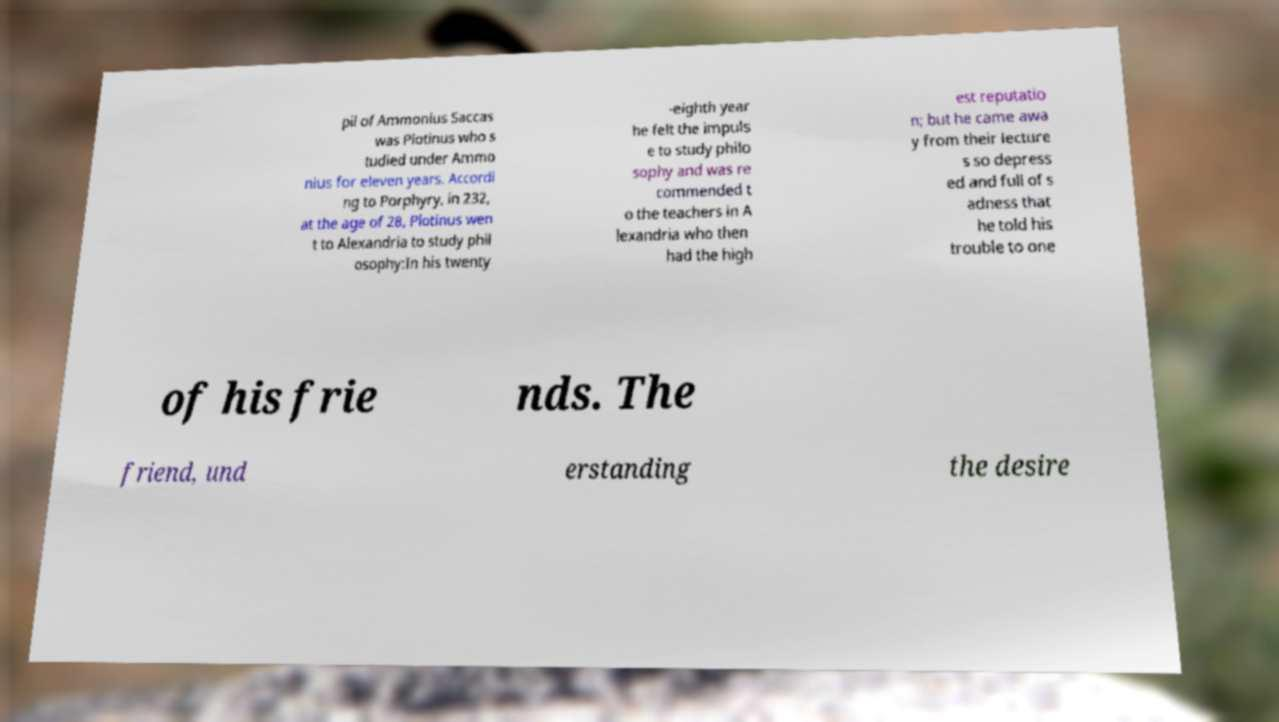Could you extract and type out the text from this image? pil of Ammonius Saccas was Plotinus who s tudied under Ammo nius for eleven years. Accordi ng to Porphyry, in 232, at the age of 28, Plotinus wen t to Alexandria to study phil osophy:In his twenty -eighth year he felt the impuls e to study philo sophy and was re commended t o the teachers in A lexandria who then had the high est reputatio n; but he came awa y from their lecture s so depress ed and full of s adness that he told his trouble to one of his frie nds. The friend, und erstanding the desire 